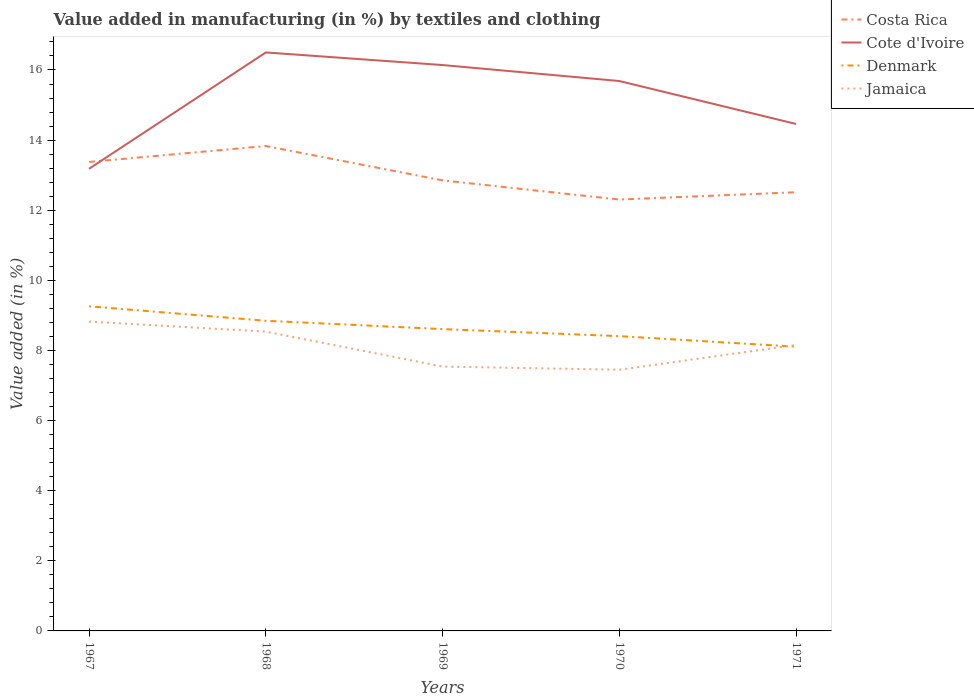Does the line corresponding to Costa Rica intersect with the line corresponding to Jamaica?
Keep it short and to the point. No. Across all years, what is the maximum percentage of value added in manufacturing by textiles and clothing in Denmark?
Your answer should be very brief. 8.11. What is the total percentage of value added in manufacturing by textiles and clothing in Cote d'Ivoire in the graph?
Your answer should be compact. 0.82. What is the difference between the highest and the second highest percentage of value added in manufacturing by textiles and clothing in Denmark?
Your answer should be very brief. 1.15. Does the graph contain any zero values?
Give a very brief answer. No. Does the graph contain grids?
Your answer should be very brief. No. What is the title of the graph?
Ensure brevity in your answer.  Value added in manufacturing (in %) by textiles and clothing. What is the label or title of the Y-axis?
Give a very brief answer. Value added (in %). What is the Value added (in %) in Costa Rica in 1967?
Provide a short and direct response. 13.38. What is the Value added (in %) in Cote d'Ivoire in 1967?
Your answer should be very brief. 13.18. What is the Value added (in %) of Denmark in 1967?
Ensure brevity in your answer.  9.26. What is the Value added (in %) of Jamaica in 1967?
Your answer should be very brief. 8.82. What is the Value added (in %) of Costa Rica in 1968?
Provide a succinct answer. 13.83. What is the Value added (in %) of Cote d'Ivoire in 1968?
Provide a succinct answer. 16.5. What is the Value added (in %) in Denmark in 1968?
Give a very brief answer. 8.85. What is the Value added (in %) of Jamaica in 1968?
Keep it short and to the point. 8.54. What is the Value added (in %) of Costa Rica in 1969?
Provide a succinct answer. 12.85. What is the Value added (in %) in Cote d'Ivoire in 1969?
Offer a terse response. 16.14. What is the Value added (in %) of Denmark in 1969?
Your response must be concise. 8.61. What is the Value added (in %) in Jamaica in 1969?
Your answer should be very brief. 7.54. What is the Value added (in %) of Costa Rica in 1970?
Ensure brevity in your answer.  12.3. What is the Value added (in %) of Cote d'Ivoire in 1970?
Give a very brief answer. 15.68. What is the Value added (in %) in Denmark in 1970?
Provide a succinct answer. 8.41. What is the Value added (in %) in Jamaica in 1970?
Keep it short and to the point. 7.45. What is the Value added (in %) in Costa Rica in 1971?
Offer a very short reply. 12.51. What is the Value added (in %) of Cote d'Ivoire in 1971?
Offer a very short reply. 14.46. What is the Value added (in %) in Denmark in 1971?
Make the answer very short. 8.11. What is the Value added (in %) of Jamaica in 1971?
Your answer should be very brief. 8.16. Across all years, what is the maximum Value added (in %) of Costa Rica?
Give a very brief answer. 13.83. Across all years, what is the maximum Value added (in %) of Cote d'Ivoire?
Give a very brief answer. 16.5. Across all years, what is the maximum Value added (in %) in Denmark?
Offer a terse response. 9.26. Across all years, what is the maximum Value added (in %) in Jamaica?
Give a very brief answer. 8.82. Across all years, what is the minimum Value added (in %) of Costa Rica?
Offer a very short reply. 12.3. Across all years, what is the minimum Value added (in %) of Cote d'Ivoire?
Your answer should be compact. 13.18. Across all years, what is the minimum Value added (in %) in Denmark?
Your response must be concise. 8.11. Across all years, what is the minimum Value added (in %) of Jamaica?
Your response must be concise. 7.45. What is the total Value added (in %) in Costa Rica in the graph?
Keep it short and to the point. 64.88. What is the total Value added (in %) in Cote d'Ivoire in the graph?
Offer a terse response. 75.97. What is the total Value added (in %) of Denmark in the graph?
Provide a short and direct response. 43.23. What is the total Value added (in %) of Jamaica in the graph?
Offer a very short reply. 40.51. What is the difference between the Value added (in %) in Costa Rica in 1967 and that in 1968?
Provide a short and direct response. -0.45. What is the difference between the Value added (in %) of Cote d'Ivoire in 1967 and that in 1968?
Your response must be concise. -3.32. What is the difference between the Value added (in %) in Denmark in 1967 and that in 1968?
Give a very brief answer. 0.41. What is the difference between the Value added (in %) of Jamaica in 1967 and that in 1968?
Offer a terse response. 0.29. What is the difference between the Value added (in %) in Costa Rica in 1967 and that in 1969?
Your response must be concise. 0.53. What is the difference between the Value added (in %) of Cote d'Ivoire in 1967 and that in 1969?
Keep it short and to the point. -2.96. What is the difference between the Value added (in %) in Denmark in 1967 and that in 1969?
Provide a succinct answer. 0.65. What is the difference between the Value added (in %) in Jamaica in 1967 and that in 1969?
Offer a terse response. 1.28. What is the difference between the Value added (in %) of Costa Rica in 1967 and that in 1970?
Offer a terse response. 1.07. What is the difference between the Value added (in %) of Cote d'Ivoire in 1967 and that in 1970?
Give a very brief answer. -2.5. What is the difference between the Value added (in %) in Denmark in 1967 and that in 1970?
Your response must be concise. 0.85. What is the difference between the Value added (in %) of Jamaica in 1967 and that in 1970?
Your answer should be compact. 1.37. What is the difference between the Value added (in %) of Costa Rica in 1967 and that in 1971?
Provide a short and direct response. 0.86. What is the difference between the Value added (in %) of Cote d'Ivoire in 1967 and that in 1971?
Offer a terse response. -1.28. What is the difference between the Value added (in %) in Denmark in 1967 and that in 1971?
Offer a terse response. 1.15. What is the difference between the Value added (in %) in Jamaica in 1967 and that in 1971?
Ensure brevity in your answer.  0.67. What is the difference between the Value added (in %) in Costa Rica in 1968 and that in 1969?
Offer a very short reply. 0.98. What is the difference between the Value added (in %) of Cote d'Ivoire in 1968 and that in 1969?
Offer a terse response. 0.36. What is the difference between the Value added (in %) in Denmark in 1968 and that in 1969?
Ensure brevity in your answer.  0.24. What is the difference between the Value added (in %) in Costa Rica in 1968 and that in 1970?
Your answer should be compact. 1.53. What is the difference between the Value added (in %) of Cote d'Ivoire in 1968 and that in 1970?
Your answer should be very brief. 0.82. What is the difference between the Value added (in %) in Denmark in 1968 and that in 1970?
Provide a succinct answer. 0.44. What is the difference between the Value added (in %) of Jamaica in 1968 and that in 1970?
Your response must be concise. 1.09. What is the difference between the Value added (in %) in Costa Rica in 1968 and that in 1971?
Offer a very short reply. 1.32. What is the difference between the Value added (in %) of Cote d'Ivoire in 1968 and that in 1971?
Make the answer very short. 2.04. What is the difference between the Value added (in %) of Denmark in 1968 and that in 1971?
Ensure brevity in your answer.  0.74. What is the difference between the Value added (in %) of Jamaica in 1968 and that in 1971?
Make the answer very short. 0.38. What is the difference between the Value added (in %) in Costa Rica in 1969 and that in 1970?
Your answer should be very brief. 0.55. What is the difference between the Value added (in %) in Cote d'Ivoire in 1969 and that in 1970?
Keep it short and to the point. 0.46. What is the difference between the Value added (in %) in Denmark in 1969 and that in 1970?
Ensure brevity in your answer.  0.2. What is the difference between the Value added (in %) of Jamaica in 1969 and that in 1970?
Keep it short and to the point. 0.09. What is the difference between the Value added (in %) in Costa Rica in 1969 and that in 1971?
Keep it short and to the point. 0.34. What is the difference between the Value added (in %) of Cote d'Ivoire in 1969 and that in 1971?
Your answer should be compact. 1.68. What is the difference between the Value added (in %) in Denmark in 1969 and that in 1971?
Offer a very short reply. 0.5. What is the difference between the Value added (in %) in Jamaica in 1969 and that in 1971?
Give a very brief answer. -0.62. What is the difference between the Value added (in %) of Costa Rica in 1970 and that in 1971?
Give a very brief answer. -0.21. What is the difference between the Value added (in %) in Cote d'Ivoire in 1970 and that in 1971?
Provide a short and direct response. 1.22. What is the difference between the Value added (in %) of Denmark in 1970 and that in 1971?
Your answer should be compact. 0.3. What is the difference between the Value added (in %) in Jamaica in 1970 and that in 1971?
Provide a succinct answer. -0.71. What is the difference between the Value added (in %) in Costa Rica in 1967 and the Value added (in %) in Cote d'Ivoire in 1968?
Your answer should be very brief. -3.12. What is the difference between the Value added (in %) in Costa Rica in 1967 and the Value added (in %) in Denmark in 1968?
Keep it short and to the point. 4.53. What is the difference between the Value added (in %) of Costa Rica in 1967 and the Value added (in %) of Jamaica in 1968?
Your answer should be very brief. 4.84. What is the difference between the Value added (in %) in Cote d'Ivoire in 1967 and the Value added (in %) in Denmark in 1968?
Keep it short and to the point. 4.33. What is the difference between the Value added (in %) of Cote d'Ivoire in 1967 and the Value added (in %) of Jamaica in 1968?
Your answer should be compact. 4.64. What is the difference between the Value added (in %) of Denmark in 1967 and the Value added (in %) of Jamaica in 1968?
Make the answer very short. 0.72. What is the difference between the Value added (in %) of Costa Rica in 1967 and the Value added (in %) of Cote d'Ivoire in 1969?
Your response must be concise. -2.76. What is the difference between the Value added (in %) in Costa Rica in 1967 and the Value added (in %) in Denmark in 1969?
Provide a short and direct response. 4.77. What is the difference between the Value added (in %) in Costa Rica in 1967 and the Value added (in %) in Jamaica in 1969?
Your answer should be compact. 5.84. What is the difference between the Value added (in %) in Cote d'Ivoire in 1967 and the Value added (in %) in Denmark in 1969?
Your answer should be very brief. 4.57. What is the difference between the Value added (in %) in Cote d'Ivoire in 1967 and the Value added (in %) in Jamaica in 1969?
Your response must be concise. 5.64. What is the difference between the Value added (in %) of Denmark in 1967 and the Value added (in %) of Jamaica in 1969?
Your answer should be very brief. 1.72. What is the difference between the Value added (in %) in Costa Rica in 1967 and the Value added (in %) in Cote d'Ivoire in 1970?
Keep it short and to the point. -2.31. What is the difference between the Value added (in %) of Costa Rica in 1967 and the Value added (in %) of Denmark in 1970?
Offer a terse response. 4.97. What is the difference between the Value added (in %) in Costa Rica in 1967 and the Value added (in %) in Jamaica in 1970?
Keep it short and to the point. 5.93. What is the difference between the Value added (in %) in Cote d'Ivoire in 1967 and the Value added (in %) in Denmark in 1970?
Offer a terse response. 4.77. What is the difference between the Value added (in %) of Cote d'Ivoire in 1967 and the Value added (in %) of Jamaica in 1970?
Your answer should be very brief. 5.73. What is the difference between the Value added (in %) of Denmark in 1967 and the Value added (in %) of Jamaica in 1970?
Make the answer very short. 1.81. What is the difference between the Value added (in %) in Costa Rica in 1967 and the Value added (in %) in Cote d'Ivoire in 1971?
Offer a very short reply. -1.08. What is the difference between the Value added (in %) of Costa Rica in 1967 and the Value added (in %) of Denmark in 1971?
Your response must be concise. 5.27. What is the difference between the Value added (in %) in Costa Rica in 1967 and the Value added (in %) in Jamaica in 1971?
Keep it short and to the point. 5.22. What is the difference between the Value added (in %) in Cote d'Ivoire in 1967 and the Value added (in %) in Denmark in 1971?
Make the answer very short. 5.07. What is the difference between the Value added (in %) in Cote d'Ivoire in 1967 and the Value added (in %) in Jamaica in 1971?
Your answer should be very brief. 5.02. What is the difference between the Value added (in %) of Denmark in 1967 and the Value added (in %) of Jamaica in 1971?
Your answer should be very brief. 1.1. What is the difference between the Value added (in %) of Costa Rica in 1968 and the Value added (in %) of Cote d'Ivoire in 1969?
Provide a short and direct response. -2.31. What is the difference between the Value added (in %) of Costa Rica in 1968 and the Value added (in %) of Denmark in 1969?
Your response must be concise. 5.22. What is the difference between the Value added (in %) in Costa Rica in 1968 and the Value added (in %) in Jamaica in 1969?
Your answer should be very brief. 6.29. What is the difference between the Value added (in %) of Cote d'Ivoire in 1968 and the Value added (in %) of Denmark in 1969?
Give a very brief answer. 7.89. What is the difference between the Value added (in %) of Cote d'Ivoire in 1968 and the Value added (in %) of Jamaica in 1969?
Keep it short and to the point. 8.96. What is the difference between the Value added (in %) of Denmark in 1968 and the Value added (in %) of Jamaica in 1969?
Give a very brief answer. 1.31. What is the difference between the Value added (in %) in Costa Rica in 1968 and the Value added (in %) in Cote d'Ivoire in 1970?
Offer a very short reply. -1.85. What is the difference between the Value added (in %) in Costa Rica in 1968 and the Value added (in %) in Denmark in 1970?
Your answer should be very brief. 5.42. What is the difference between the Value added (in %) of Costa Rica in 1968 and the Value added (in %) of Jamaica in 1970?
Make the answer very short. 6.38. What is the difference between the Value added (in %) of Cote d'Ivoire in 1968 and the Value added (in %) of Denmark in 1970?
Offer a very short reply. 8.09. What is the difference between the Value added (in %) in Cote d'Ivoire in 1968 and the Value added (in %) in Jamaica in 1970?
Your answer should be compact. 9.05. What is the difference between the Value added (in %) in Denmark in 1968 and the Value added (in %) in Jamaica in 1970?
Provide a succinct answer. 1.4. What is the difference between the Value added (in %) in Costa Rica in 1968 and the Value added (in %) in Cote d'Ivoire in 1971?
Keep it short and to the point. -0.63. What is the difference between the Value added (in %) in Costa Rica in 1968 and the Value added (in %) in Denmark in 1971?
Your answer should be very brief. 5.72. What is the difference between the Value added (in %) in Costa Rica in 1968 and the Value added (in %) in Jamaica in 1971?
Offer a terse response. 5.67. What is the difference between the Value added (in %) in Cote d'Ivoire in 1968 and the Value added (in %) in Denmark in 1971?
Provide a succinct answer. 8.39. What is the difference between the Value added (in %) in Cote d'Ivoire in 1968 and the Value added (in %) in Jamaica in 1971?
Give a very brief answer. 8.34. What is the difference between the Value added (in %) of Denmark in 1968 and the Value added (in %) of Jamaica in 1971?
Provide a short and direct response. 0.69. What is the difference between the Value added (in %) in Costa Rica in 1969 and the Value added (in %) in Cote d'Ivoire in 1970?
Give a very brief answer. -2.83. What is the difference between the Value added (in %) in Costa Rica in 1969 and the Value added (in %) in Denmark in 1970?
Offer a terse response. 4.44. What is the difference between the Value added (in %) of Costa Rica in 1969 and the Value added (in %) of Jamaica in 1970?
Offer a terse response. 5.4. What is the difference between the Value added (in %) of Cote d'Ivoire in 1969 and the Value added (in %) of Denmark in 1970?
Provide a short and direct response. 7.73. What is the difference between the Value added (in %) of Cote d'Ivoire in 1969 and the Value added (in %) of Jamaica in 1970?
Offer a terse response. 8.69. What is the difference between the Value added (in %) in Denmark in 1969 and the Value added (in %) in Jamaica in 1970?
Give a very brief answer. 1.16. What is the difference between the Value added (in %) in Costa Rica in 1969 and the Value added (in %) in Cote d'Ivoire in 1971?
Your response must be concise. -1.61. What is the difference between the Value added (in %) of Costa Rica in 1969 and the Value added (in %) of Denmark in 1971?
Offer a terse response. 4.74. What is the difference between the Value added (in %) in Costa Rica in 1969 and the Value added (in %) in Jamaica in 1971?
Make the answer very short. 4.69. What is the difference between the Value added (in %) in Cote d'Ivoire in 1969 and the Value added (in %) in Denmark in 1971?
Offer a terse response. 8.03. What is the difference between the Value added (in %) in Cote d'Ivoire in 1969 and the Value added (in %) in Jamaica in 1971?
Keep it short and to the point. 7.98. What is the difference between the Value added (in %) of Denmark in 1969 and the Value added (in %) of Jamaica in 1971?
Provide a succinct answer. 0.45. What is the difference between the Value added (in %) of Costa Rica in 1970 and the Value added (in %) of Cote d'Ivoire in 1971?
Your response must be concise. -2.16. What is the difference between the Value added (in %) of Costa Rica in 1970 and the Value added (in %) of Denmark in 1971?
Your answer should be compact. 4.2. What is the difference between the Value added (in %) of Costa Rica in 1970 and the Value added (in %) of Jamaica in 1971?
Your answer should be very brief. 4.15. What is the difference between the Value added (in %) in Cote d'Ivoire in 1970 and the Value added (in %) in Denmark in 1971?
Your response must be concise. 7.58. What is the difference between the Value added (in %) in Cote d'Ivoire in 1970 and the Value added (in %) in Jamaica in 1971?
Ensure brevity in your answer.  7.53. What is the difference between the Value added (in %) in Denmark in 1970 and the Value added (in %) in Jamaica in 1971?
Provide a short and direct response. 0.25. What is the average Value added (in %) in Costa Rica per year?
Give a very brief answer. 12.98. What is the average Value added (in %) of Cote d'Ivoire per year?
Keep it short and to the point. 15.19. What is the average Value added (in %) of Denmark per year?
Offer a very short reply. 8.65. What is the average Value added (in %) in Jamaica per year?
Offer a terse response. 8.1. In the year 1967, what is the difference between the Value added (in %) in Costa Rica and Value added (in %) in Cote d'Ivoire?
Your response must be concise. 0.2. In the year 1967, what is the difference between the Value added (in %) of Costa Rica and Value added (in %) of Denmark?
Keep it short and to the point. 4.12. In the year 1967, what is the difference between the Value added (in %) of Costa Rica and Value added (in %) of Jamaica?
Ensure brevity in your answer.  4.55. In the year 1967, what is the difference between the Value added (in %) of Cote d'Ivoire and Value added (in %) of Denmark?
Ensure brevity in your answer.  3.92. In the year 1967, what is the difference between the Value added (in %) in Cote d'Ivoire and Value added (in %) in Jamaica?
Your answer should be compact. 4.36. In the year 1967, what is the difference between the Value added (in %) of Denmark and Value added (in %) of Jamaica?
Ensure brevity in your answer.  0.44. In the year 1968, what is the difference between the Value added (in %) of Costa Rica and Value added (in %) of Cote d'Ivoire?
Offer a very short reply. -2.67. In the year 1968, what is the difference between the Value added (in %) of Costa Rica and Value added (in %) of Denmark?
Your answer should be very brief. 4.98. In the year 1968, what is the difference between the Value added (in %) in Costa Rica and Value added (in %) in Jamaica?
Make the answer very short. 5.29. In the year 1968, what is the difference between the Value added (in %) of Cote d'Ivoire and Value added (in %) of Denmark?
Provide a succinct answer. 7.65. In the year 1968, what is the difference between the Value added (in %) of Cote d'Ivoire and Value added (in %) of Jamaica?
Keep it short and to the point. 7.96. In the year 1968, what is the difference between the Value added (in %) of Denmark and Value added (in %) of Jamaica?
Your answer should be very brief. 0.31. In the year 1969, what is the difference between the Value added (in %) in Costa Rica and Value added (in %) in Cote d'Ivoire?
Give a very brief answer. -3.29. In the year 1969, what is the difference between the Value added (in %) in Costa Rica and Value added (in %) in Denmark?
Provide a succinct answer. 4.24. In the year 1969, what is the difference between the Value added (in %) of Costa Rica and Value added (in %) of Jamaica?
Keep it short and to the point. 5.31. In the year 1969, what is the difference between the Value added (in %) in Cote d'Ivoire and Value added (in %) in Denmark?
Offer a very short reply. 7.53. In the year 1969, what is the difference between the Value added (in %) in Cote d'Ivoire and Value added (in %) in Jamaica?
Offer a terse response. 8.6. In the year 1969, what is the difference between the Value added (in %) in Denmark and Value added (in %) in Jamaica?
Keep it short and to the point. 1.07. In the year 1970, what is the difference between the Value added (in %) in Costa Rica and Value added (in %) in Cote d'Ivoire?
Your answer should be compact. -3.38. In the year 1970, what is the difference between the Value added (in %) of Costa Rica and Value added (in %) of Denmark?
Make the answer very short. 3.9. In the year 1970, what is the difference between the Value added (in %) in Costa Rica and Value added (in %) in Jamaica?
Make the answer very short. 4.86. In the year 1970, what is the difference between the Value added (in %) in Cote d'Ivoire and Value added (in %) in Denmark?
Keep it short and to the point. 7.28. In the year 1970, what is the difference between the Value added (in %) of Cote d'Ivoire and Value added (in %) of Jamaica?
Give a very brief answer. 8.24. In the year 1970, what is the difference between the Value added (in %) in Denmark and Value added (in %) in Jamaica?
Give a very brief answer. 0.96. In the year 1971, what is the difference between the Value added (in %) in Costa Rica and Value added (in %) in Cote d'Ivoire?
Provide a succinct answer. -1.95. In the year 1971, what is the difference between the Value added (in %) of Costa Rica and Value added (in %) of Denmark?
Your answer should be compact. 4.41. In the year 1971, what is the difference between the Value added (in %) in Costa Rica and Value added (in %) in Jamaica?
Provide a succinct answer. 4.36. In the year 1971, what is the difference between the Value added (in %) of Cote d'Ivoire and Value added (in %) of Denmark?
Make the answer very short. 6.35. In the year 1971, what is the difference between the Value added (in %) of Cote d'Ivoire and Value added (in %) of Jamaica?
Your response must be concise. 6.3. In the year 1971, what is the difference between the Value added (in %) of Denmark and Value added (in %) of Jamaica?
Provide a succinct answer. -0.05. What is the ratio of the Value added (in %) of Costa Rica in 1967 to that in 1968?
Your response must be concise. 0.97. What is the ratio of the Value added (in %) of Cote d'Ivoire in 1967 to that in 1968?
Offer a terse response. 0.8. What is the ratio of the Value added (in %) of Denmark in 1967 to that in 1968?
Offer a terse response. 1.05. What is the ratio of the Value added (in %) in Jamaica in 1967 to that in 1968?
Ensure brevity in your answer.  1.03. What is the ratio of the Value added (in %) of Costa Rica in 1967 to that in 1969?
Ensure brevity in your answer.  1.04. What is the ratio of the Value added (in %) in Cote d'Ivoire in 1967 to that in 1969?
Ensure brevity in your answer.  0.82. What is the ratio of the Value added (in %) of Denmark in 1967 to that in 1969?
Make the answer very short. 1.08. What is the ratio of the Value added (in %) in Jamaica in 1967 to that in 1969?
Your answer should be compact. 1.17. What is the ratio of the Value added (in %) in Costa Rica in 1967 to that in 1970?
Offer a terse response. 1.09. What is the ratio of the Value added (in %) in Cote d'Ivoire in 1967 to that in 1970?
Your response must be concise. 0.84. What is the ratio of the Value added (in %) in Denmark in 1967 to that in 1970?
Make the answer very short. 1.1. What is the ratio of the Value added (in %) in Jamaica in 1967 to that in 1970?
Offer a very short reply. 1.18. What is the ratio of the Value added (in %) of Costa Rica in 1967 to that in 1971?
Your response must be concise. 1.07. What is the ratio of the Value added (in %) in Cote d'Ivoire in 1967 to that in 1971?
Keep it short and to the point. 0.91. What is the ratio of the Value added (in %) of Denmark in 1967 to that in 1971?
Provide a succinct answer. 1.14. What is the ratio of the Value added (in %) in Jamaica in 1967 to that in 1971?
Make the answer very short. 1.08. What is the ratio of the Value added (in %) in Costa Rica in 1968 to that in 1969?
Your answer should be very brief. 1.08. What is the ratio of the Value added (in %) of Cote d'Ivoire in 1968 to that in 1969?
Your response must be concise. 1.02. What is the ratio of the Value added (in %) in Denmark in 1968 to that in 1969?
Make the answer very short. 1.03. What is the ratio of the Value added (in %) of Jamaica in 1968 to that in 1969?
Ensure brevity in your answer.  1.13. What is the ratio of the Value added (in %) in Costa Rica in 1968 to that in 1970?
Keep it short and to the point. 1.12. What is the ratio of the Value added (in %) of Cote d'Ivoire in 1968 to that in 1970?
Your answer should be very brief. 1.05. What is the ratio of the Value added (in %) in Denmark in 1968 to that in 1970?
Your response must be concise. 1.05. What is the ratio of the Value added (in %) of Jamaica in 1968 to that in 1970?
Provide a succinct answer. 1.15. What is the ratio of the Value added (in %) of Costa Rica in 1968 to that in 1971?
Your answer should be very brief. 1.11. What is the ratio of the Value added (in %) of Cote d'Ivoire in 1968 to that in 1971?
Ensure brevity in your answer.  1.14. What is the ratio of the Value added (in %) in Denmark in 1968 to that in 1971?
Keep it short and to the point. 1.09. What is the ratio of the Value added (in %) in Jamaica in 1968 to that in 1971?
Your response must be concise. 1.05. What is the ratio of the Value added (in %) of Costa Rica in 1969 to that in 1970?
Provide a succinct answer. 1.04. What is the ratio of the Value added (in %) of Cote d'Ivoire in 1969 to that in 1970?
Give a very brief answer. 1.03. What is the ratio of the Value added (in %) in Denmark in 1969 to that in 1970?
Your answer should be compact. 1.02. What is the ratio of the Value added (in %) of Jamaica in 1969 to that in 1970?
Give a very brief answer. 1.01. What is the ratio of the Value added (in %) in Costa Rica in 1969 to that in 1971?
Give a very brief answer. 1.03. What is the ratio of the Value added (in %) in Cote d'Ivoire in 1969 to that in 1971?
Keep it short and to the point. 1.12. What is the ratio of the Value added (in %) in Denmark in 1969 to that in 1971?
Your answer should be compact. 1.06. What is the ratio of the Value added (in %) in Jamaica in 1969 to that in 1971?
Offer a very short reply. 0.92. What is the ratio of the Value added (in %) in Costa Rica in 1970 to that in 1971?
Your response must be concise. 0.98. What is the ratio of the Value added (in %) of Cote d'Ivoire in 1970 to that in 1971?
Your response must be concise. 1.08. What is the ratio of the Value added (in %) in Denmark in 1970 to that in 1971?
Provide a succinct answer. 1.04. What is the ratio of the Value added (in %) of Jamaica in 1970 to that in 1971?
Provide a short and direct response. 0.91. What is the difference between the highest and the second highest Value added (in %) of Costa Rica?
Offer a very short reply. 0.45. What is the difference between the highest and the second highest Value added (in %) of Cote d'Ivoire?
Your answer should be very brief. 0.36. What is the difference between the highest and the second highest Value added (in %) of Denmark?
Your response must be concise. 0.41. What is the difference between the highest and the second highest Value added (in %) of Jamaica?
Your answer should be compact. 0.29. What is the difference between the highest and the lowest Value added (in %) of Costa Rica?
Keep it short and to the point. 1.53. What is the difference between the highest and the lowest Value added (in %) in Cote d'Ivoire?
Offer a very short reply. 3.32. What is the difference between the highest and the lowest Value added (in %) in Denmark?
Make the answer very short. 1.15. What is the difference between the highest and the lowest Value added (in %) of Jamaica?
Keep it short and to the point. 1.37. 